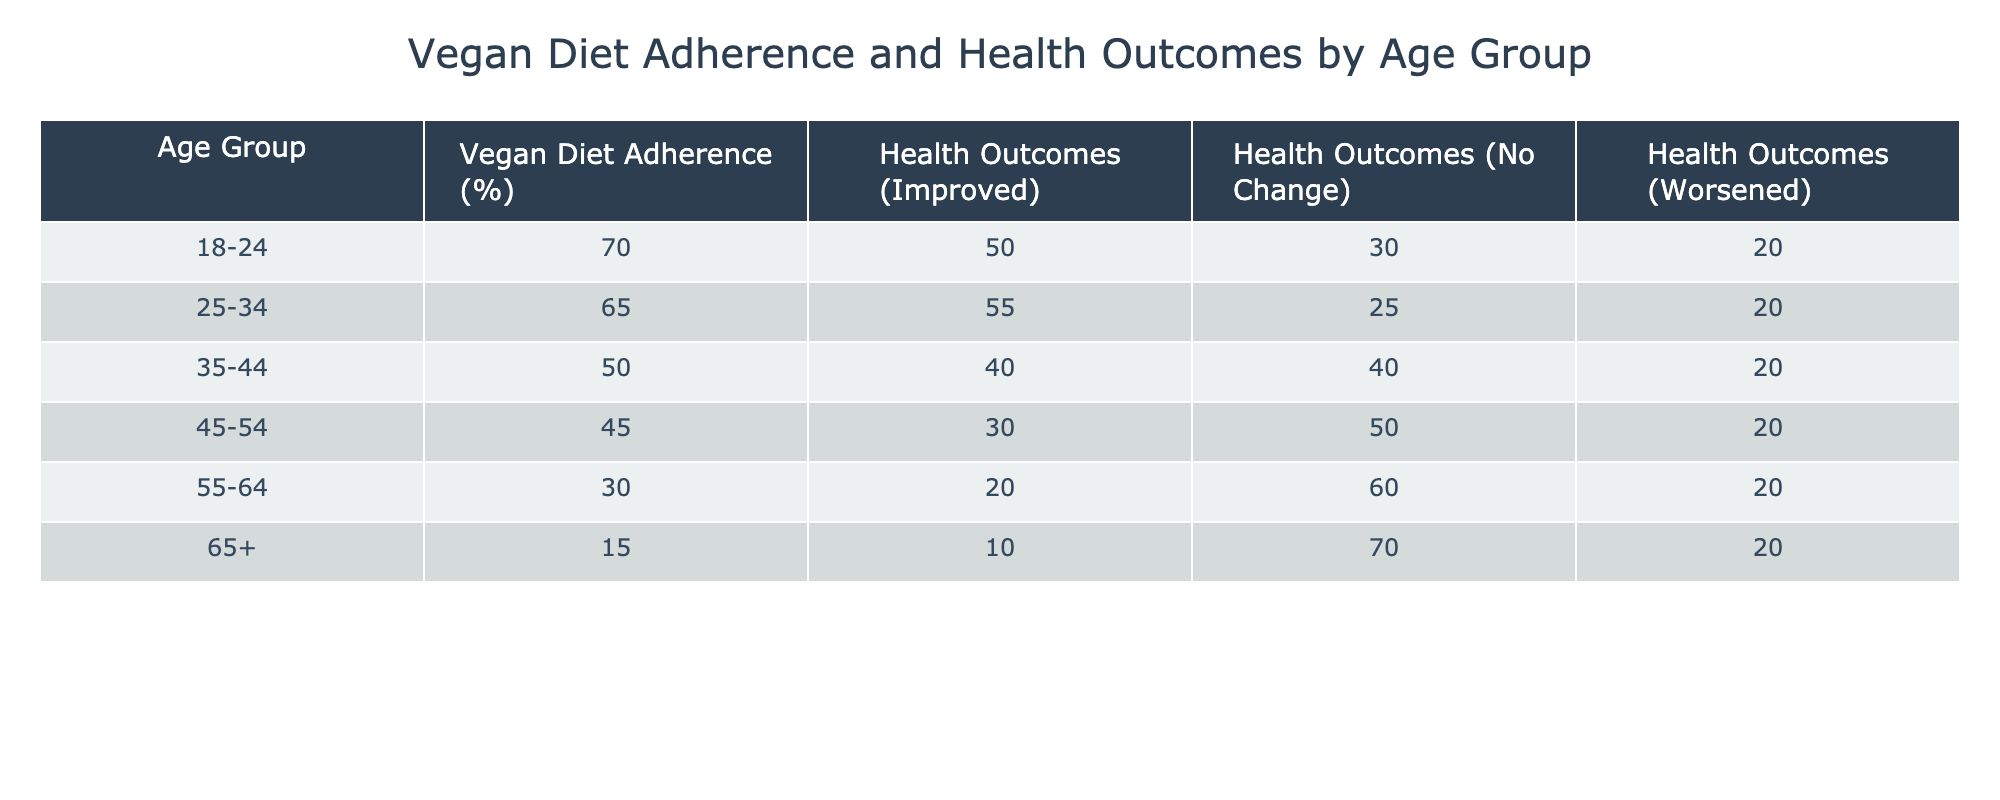What is the vegan diet adherence percentage for the age group 25-34? The table shows that the vegan diet adherence for the age group 25-34 is 65%.
Answer: 65% Which age group has the highest percentage of health outcomes that improved? By looking at the "Health Outcomes (Improved)" column, the age group 25-34 has the highest percentage at 55%.
Answer: 55% What is the difference in the percentage of health outcomes that worsened between the 18-24 and 65+ age groups? The health outcomes that worsened for the age group 18-24 is 20%, and for the age group 65+, it is also 20%. Thus, the difference is 20% - 20% = 0%.
Answer: 0% Is it true that individuals in the 55-64 age group have a lower percentage of health outcomes that improved than those in the 18-24 age group? For the age group 55-64, the health outcomes that improved is 20%, while for the age group 18-24, it is 50%. Since 20% is less than 50%, the statement is true.
Answer: Yes What is the average vegan diet adherence percentage for the age groups 45-54 and 55-64? The percentages for these age groups are 45% and 30%, respectively. To find the average, add them (45 + 30 = 75) and divide by 2, yielding an average of 37.5%.
Answer: 37.5% Which age group has the lowest percentage of health outcomes that improved? The table indicates that the age group 65+ has the lowest percentage of health outcomes that improved at 10%.
Answer: 10% What is the total percentage of health outcomes with no change for individuals aged 35-44 and 45-54 combined? The percentage for age group 35-44 is 40%, and for 45-54, it is 50%. Adding these two percentages results in 40 + 50 = 90%.
Answer: 90% Is it accurate to say that the proportion of individuals experiencing improved health outcomes decreases with age? The data shows that as age increases, the percentage of individuals reporting improved health outcomes generally decreases from 50% in 18-24 to 10% in 65+. Therefore, this statement is accurate.
Answer: Yes 